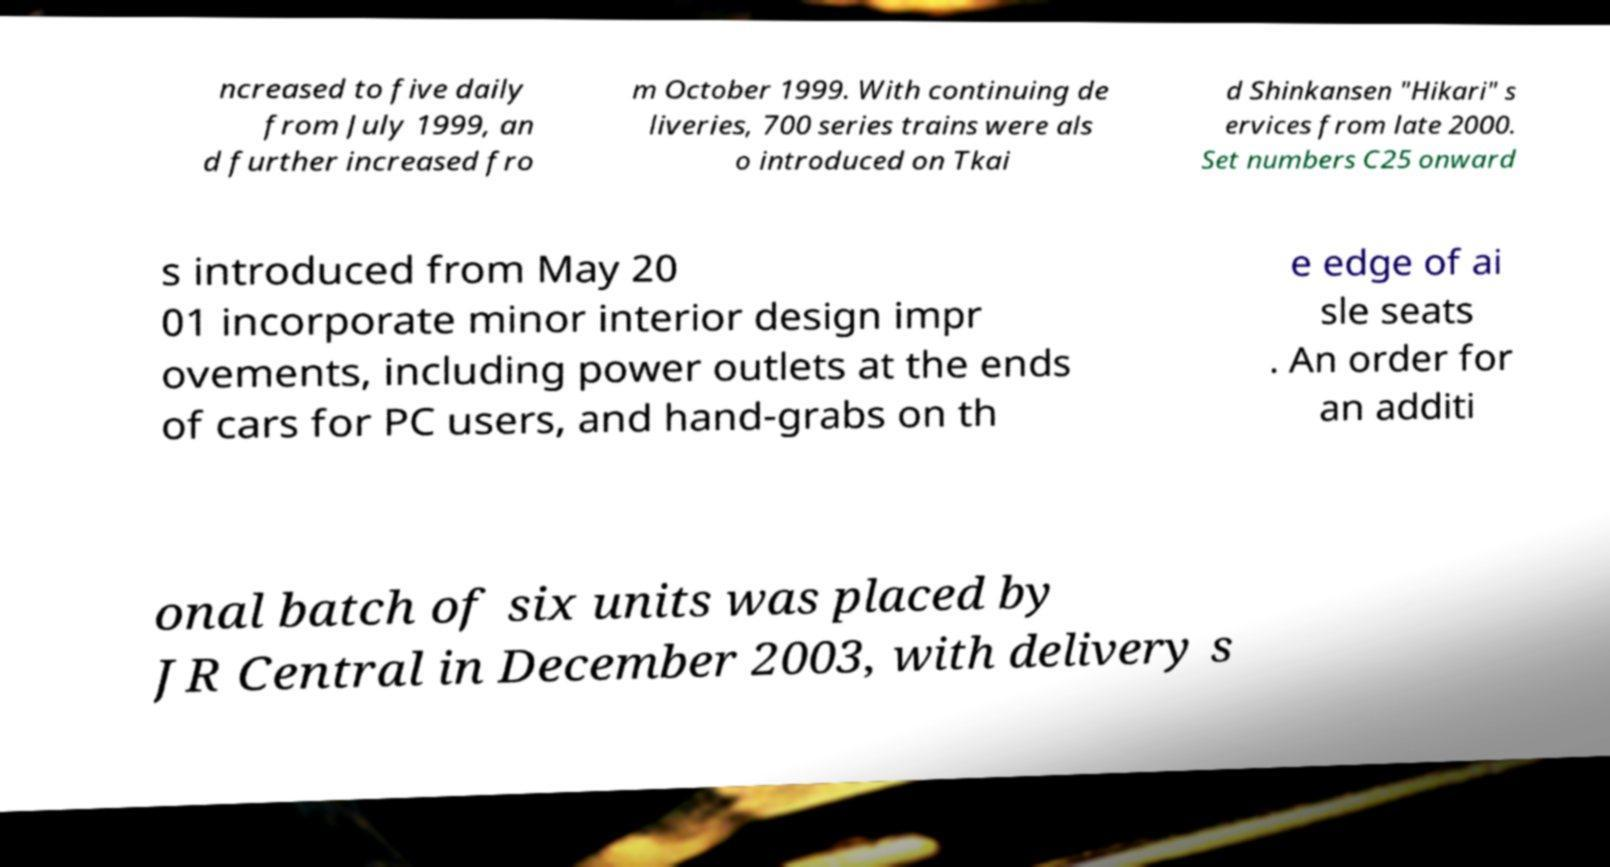Could you assist in decoding the text presented in this image and type it out clearly? ncreased to five daily from July 1999, an d further increased fro m October 1999. With continuing de liveries, 700 series trains were als o introduced on Tkai d Shinkansen "Hikari" s ervices from late 2000. Set numbers C25 onward s introduced from May 20 01 incorporate minor interior design impr ovements, including power outlets at the ends of cars for PC users, and hand-grabs on th e edge of ai sle seats . An order for an additi onal batch of six units was placed by JR Central in December 2003, with delivery s 